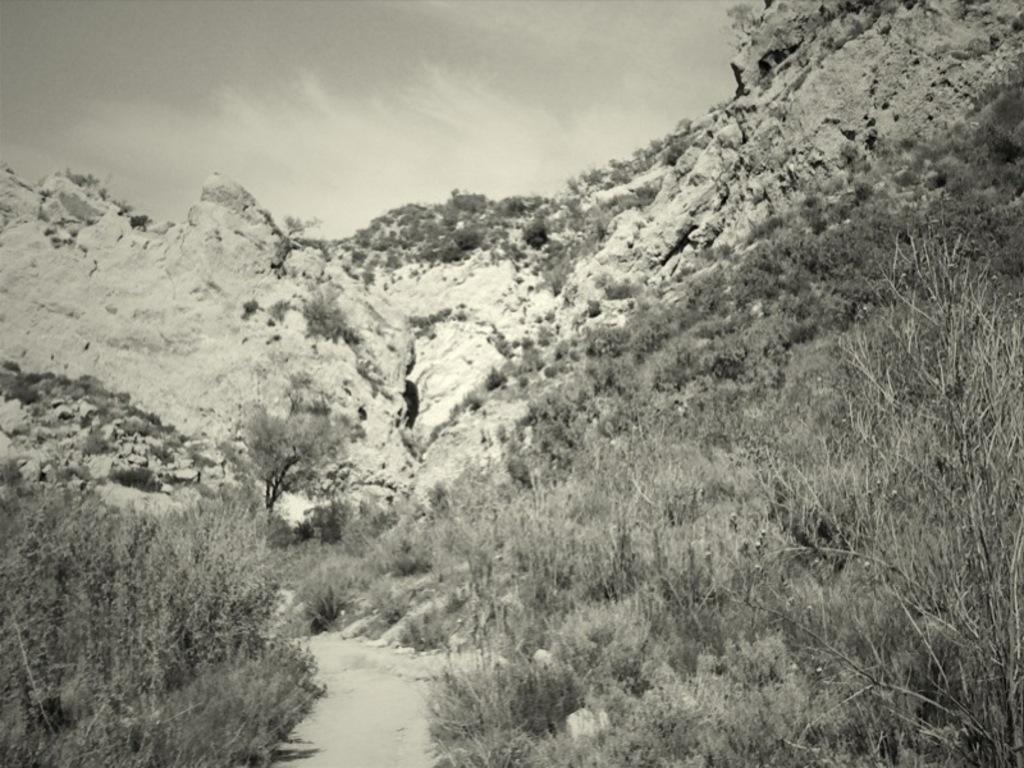In one or two sentences, can you explain what this image depicts? In this image we can see black and white picture of a group of trees, pathway, mountain and the cloudy sky. 